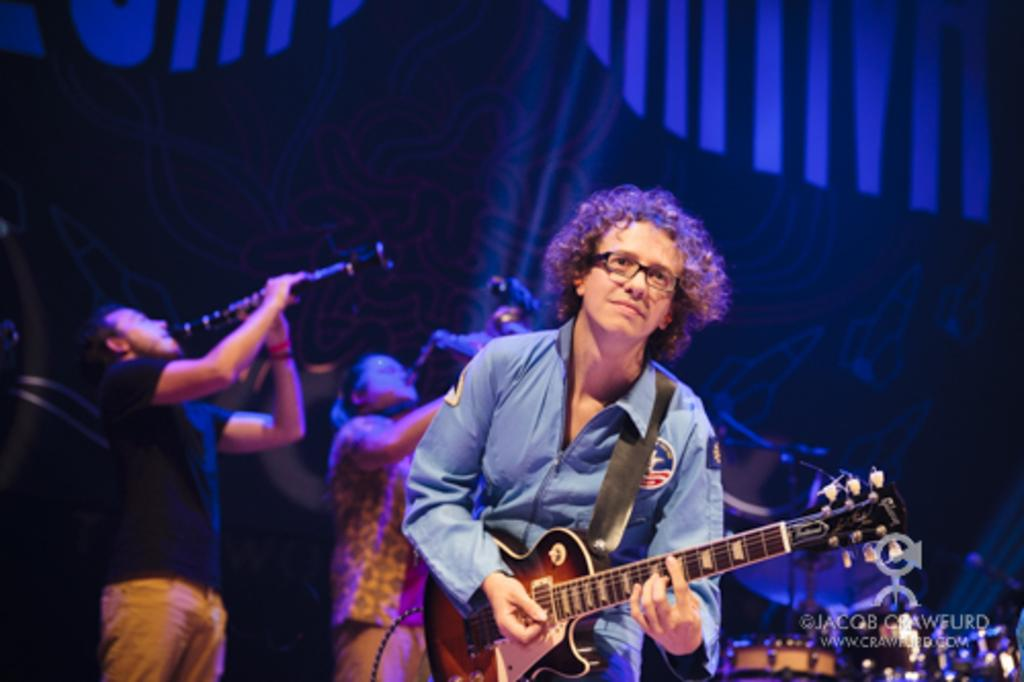What is the man wearing on his face in the image? The man is wearing spectacles in the image. What color is the shirt the man is wearing? The man is wearing a blue shirt in the image. What is the man doing in the image? The man is playing a guitar in the image. Are there other people in the image besides the man? Yes, there are other persons playing musical instruments in the image. What can be seen in the image besides the people playing musical instruments? The musical instruments themselves are visible in the image. Can you see the ocean in the background of the image? No, there is no ocean visible in the image. What type of angle is the guitar being played at in the image? The angle at which the guitar is being played cannot be determined from the image alone. 